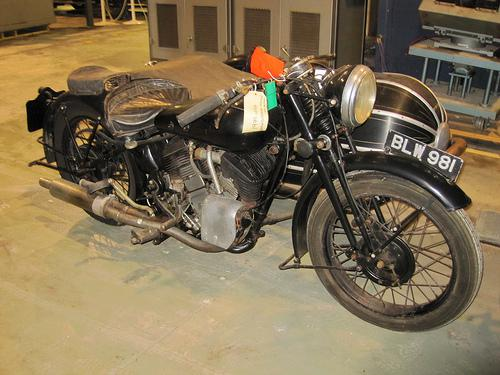Question: where is the license plate?
Choices:
A. In the back.
B. Above the front wheel.
C. In the window.
D. Between the front tires.
Answer with the letter. Answer: B Question: how many bikes are in the photo?
Choices:
A. Two.
B. Three.
C. Five.
D. One.
Answer with the letter. Answer: D Question: what type of ground is the bike on?
Choices:
A. Concrete.
B. Wood.
C. Asphalt.
D. Slate.
Answer with the letter. Answer: A Question: what is on the license?
Choices:
A. Letters and numbers.
B. The state.
C. BLW 981.
D. 45g 8ki.
Answer with the letter. Answer: C Question: how many wheels are on the bike?
Choices:
A. Three.
B. One.
C. Four.
D. Two.
Answer with the letter. Answer: D 